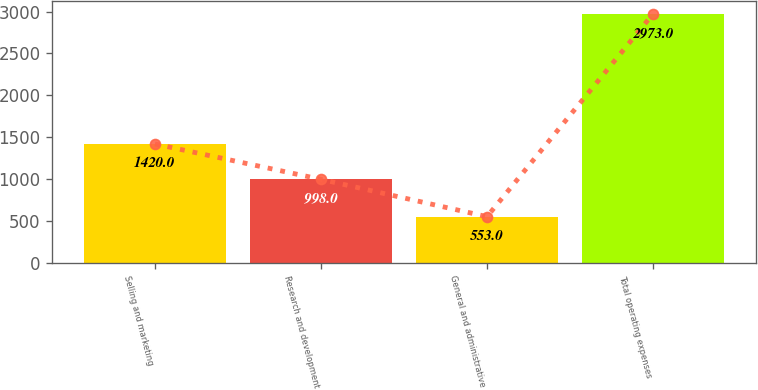Convert chart. <chart><loc_0><loc_0><loc_500><loc_500><bar_chart><fcel>Selling and marketing<fcel>Research and development<fcel>General and administrative<fcel>Total operating expenses<nl><fcel>1420<fcel>998<fcel>553<fcel>2973<nl></chart> 